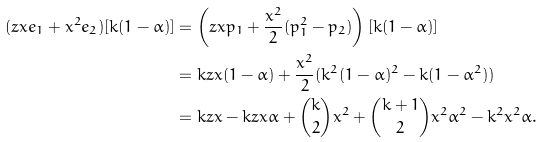Convert formula to latex. <formula><loc_0><loc_0><loc_500><loc_500>( z x e _ { 1 } + x ^ { 2 } e _ { 2 } ) [ k ( 1 - \alpha ) ] & = \left ( z x p _ { 1 } + \frac { x ^ { 2 } } { 2 } ( p _ { 1 } ^ { 2 } - p _ { 2 } ) \right ) [ k ( 1 - \alpha ) ] \\ & = k z x ( 1 - \alpha ) + \frac { x ^ { 2 } } { 2 } ( k ^ { 2 } ( 1 - \alpha ) ^ { 2 } - k ( 1 - \alpha ^ { 2 } ) ) \\ & = k z x - k z x \alpha + { k \choose 2 } x ^ { 2 } + { k + 1 \choose 2 } x ^ { 2 } \alpha ^ { 2 } - k ^ { 2 } x ^ { 2 } \alpha .</formula> 